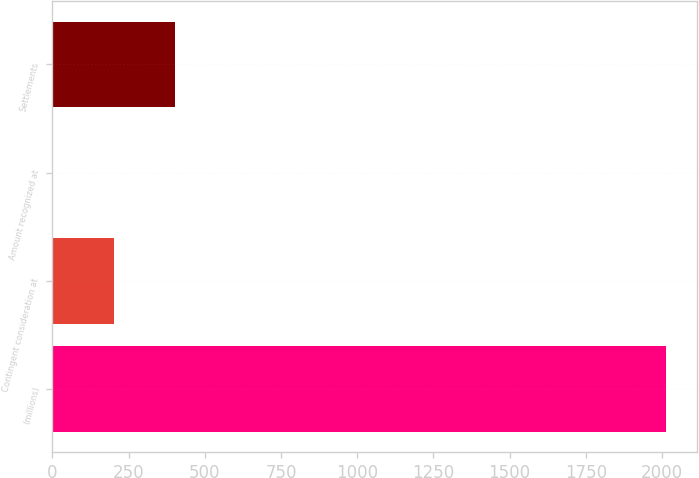Convert chart. <chart><loc_0><loc_0><loc_500><loc_500><bar_chart><fcel>(millions)<fcel>Contingent consideration at<fcel>Amount recognized at<fcel>Settlements<nl><fcel>2014<fcel>201.76<fcel>0.4<fcel>403.12<nl></chart> 